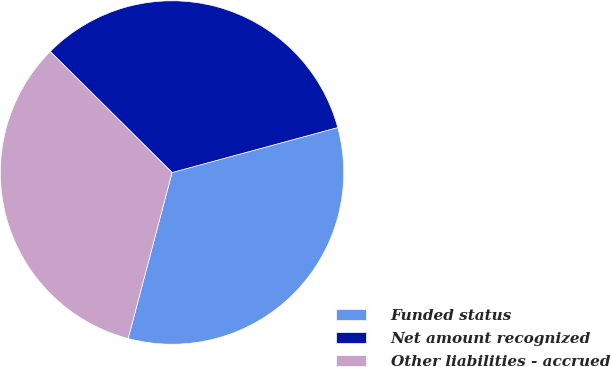<chart> <loc_0><loc_0><loc_500><loc_500><pie_chart><fcel>Funded status<fcel>Net amount recognized<fcel>Other liabilities - accrued<nl><fcel>33.33%<fcel>33.33%<fcel>33.33%<nl></chart> 